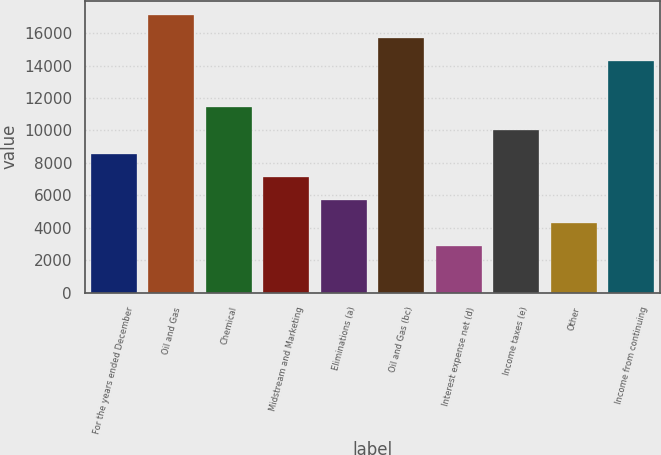Convert chart. <chart><loc_0><loc_0><loc_500><loc_500><bar_chart><fcel>For the years ended December<fcel>Oil and Gas<fcel>Chemical<fcel>Midstream and Marketing<fcel>Eliminations (a)<fcel>Oil and Gas (bc)<fcel>Interest expense net (d)<fcel>Income taxes (e)<fcel>Other<fcel>Income from continuing<nl><fcel>8567.81<fcel>17130<fcel>11421.9<fcel>7140.77<fcel>5713.73<fcel>15703<fcel>2859.65<fcel>9994.85<fcel>4286.69<fcel>14276<nl></chart> 